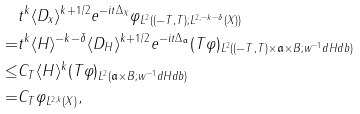Convert formula to latex. <formula><loc_0><loc_0><loc_500><loc_500>& \| t ^ { k } \langle D _ { x } \rangle ^ { k + 1 / 2 } e ^ { - i t \Delta _ { X } } \varphi \| _ { L ^ { 2 } ( ( - T , T ) ; L ^ { 2 , - k - \delta } ( X ) ) } \\ = & \| t ^ { k } \langle H \rangle ^ { - k - \delta } \langle D _ { H } \rangle ^ { k + 1 / 2 } e ^ { - i t \Delta _ { \mathfrak { a } } } ( T \varphi ) \| _ { L ^ { 2 } ( ( - T , T ) \times \mathfrak { a } \times B ; w ^ { - 1 } d H d b ) } \\ \leq & C _ { T } \| \langle H \rangle ^ { k } ( T \varphi ) \| _ { L ^ { 2 } ( \mathfrak { a } \times B ; w ^ { - 1 } d H d b ) } \\ = & C _ { T } \| \varphi \| _ { L ^ { 2 , k } ( X ) } ,</formula> 